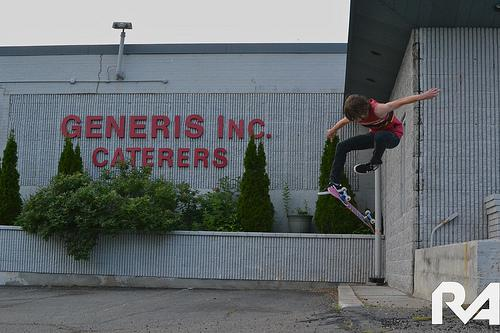Question: what is written?
Choices:
A. Generis Inc Caterers.
B. Microsoft.
C. Apple.
D. Ibm.
Answer with the letter. Answer: A Question: what is the color of the letters?
Choices:
A. Blue.
B. White.
C. Red.
D. Black.
Answer with the letter. Answer: C Question: what is the boy doing?
Choices:
A. Dancing.
B. Skating.
C. Sleeping.
D. Smiling.
Answer with the letter. Answer: B Question: what is the color of the leaves?
Choices:
A. Red.
B. White.
C. Green.
D. Yellow.
Answer with the letter. Answer: C Question: what is the color of the wall?
Choices:
A. White.
B. Black.
C. Grey.
D. Purple.
Answer with the letter. Answer: A 